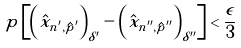Convert formula to latex. <formula><loc_0><loc_0><loc_500><loc_500>p \left [ \left ( \hat { x } _ { n ^ { \prime } , \hat { p } ^ { \prime } } \right ) _ { \delta ^ { \prime } } - \left ( \hat { x } _ { n ^ { \prime \prime } , \hat { p } ^ { \prime \prime } } \right ) _ { \delta ^ { \prime \prime } } \right ] < \frac { \epsilon } { 3 }</formula> 